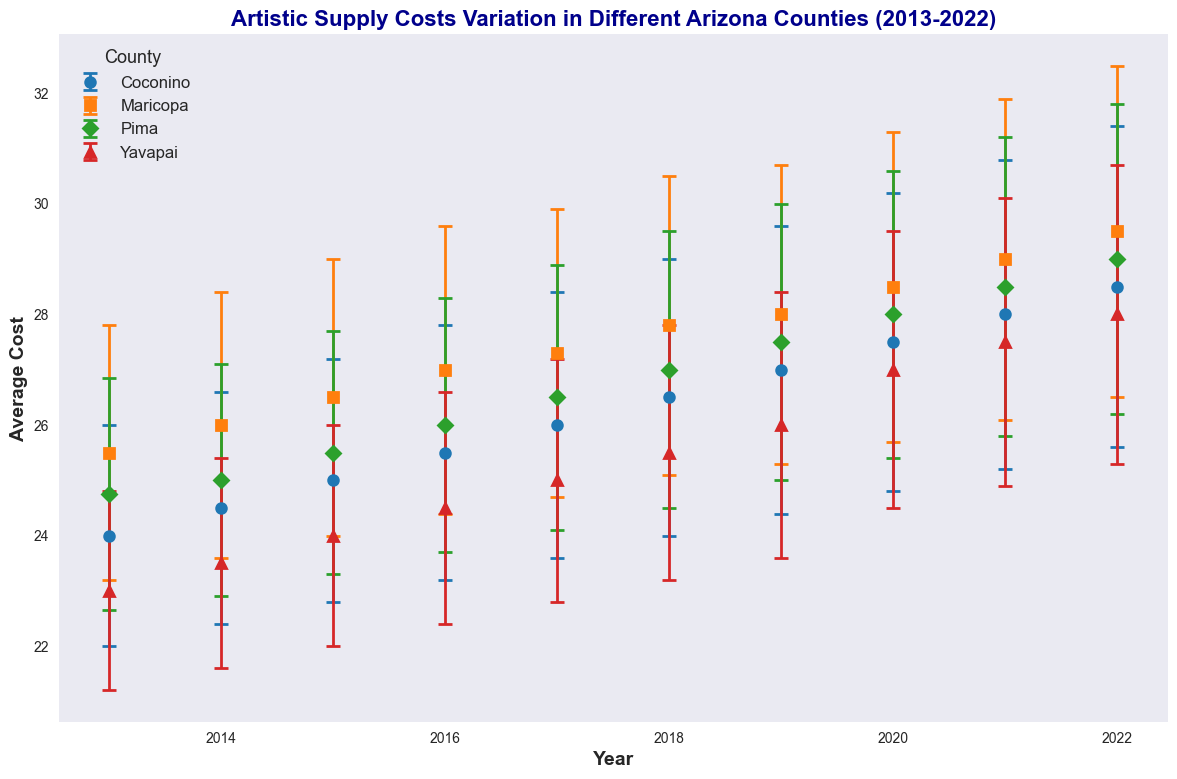What is the average cost of artistic supplies in Coconino County in 2018? Find the point where the line representing Coconino intersects with the year 2018 on the x-axis, then read the value on the y-axis.
Answer: 26.50 Between 2017 and 2022, which county showed the most significant increase in the average cost of artistic supplies? Calculate the difference between the average costs of 2022 and 2017 for each county: Maricopa (29.50 - 27.30 = 2.20), Pima (29.00 - 26.50 = 2.50), Yavapai (28.00 - 25.00 = 3.00), and Coconino (28.50 - 26.00 = 2.50). The highest difference is for Yavapai, which is 3.00.
Answer: Yavapai In 2018, which county had the lowest average cost of artistic supplies and what was it? Determine the 2018 values for each county and identify the smallest value: Maricopa (27.80), Pima (27.00), Yavapai (25.50), and Coconino (26.50). The lowest value is 25.50 in Yavapai.
Answer: Yavapai, 25.50 How did the average cost in Maricopa County change from 2013 to 2022? Subtract the 2013 value from the 2022 value: 29.50 - 25.50 = 4.00.
Answer: Increased by 4.00 Which year showed the highest overall increase in average costs across all counties compared to the previous year? Calculate the year-over-year changes for each year and each county, then sum the changes for all counties for each year. Determine the year with the highest sum. After all calculations, compare and find the year with the largest total increase.
Answer: 2020 What is the overall trend in average cost of artistic supplies in Maricopa County from 2013 to 2022? Observe the direction of the Maricopa County line from 2013 to 2022. The line is generally increasing, indicating an upward trend.
Answer: Increasing Which county displayed the highest variability (standard deviation) in 2020? Compare the standard deviation values for 2020: Maricopa (2.8), Pima (2.6), Yavapai (2.5), and Coconino (2.7). The highest standard deviation is 2.8 in Maricopa.
Answer: Maricopa Which county had the closest average cost to the overall average across all counties in 2021? Calculate the average of the 2021 average costs for all counties (Maricopa, Pima, Yavapai, and Coconino) and compare each county's average cost to this overall average: (29.00 + 28.50 + 27.50 + 28.00) / 4 = 28.25. The closest value to 28.25 is 28.00 in Coconino.
Answer: Coconino What is the difference in average cost between the highest and lowest county in 2020? Identify the highest and lowest average costs in 2020: Maricopa (28.50) and Yavapai (27.00). Subtract the lowest from the highest: 28.50 - 27.00 = 1.50.
Answer: 1.50 In which year did Pima County first surpass an average cost of 27? Scan the Pima County line and find the first year it exceeds 27. The line first exceeds 27 in 2019 (27.50).
Answer: 2019 